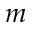Convert formula to latex. <formula><loc_0><loc_0><loc_500><loc_500>m</formula> 